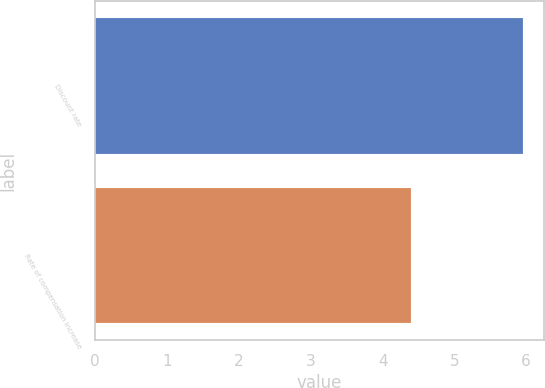Convert chart. <chart><loc_0><loc_0><loc_500><loc_500><bar_chart><fcel>Discount rate<fcel>Rate of compensation increase<nl><fcel>5.95<fcel>4.4<nl></chart> 